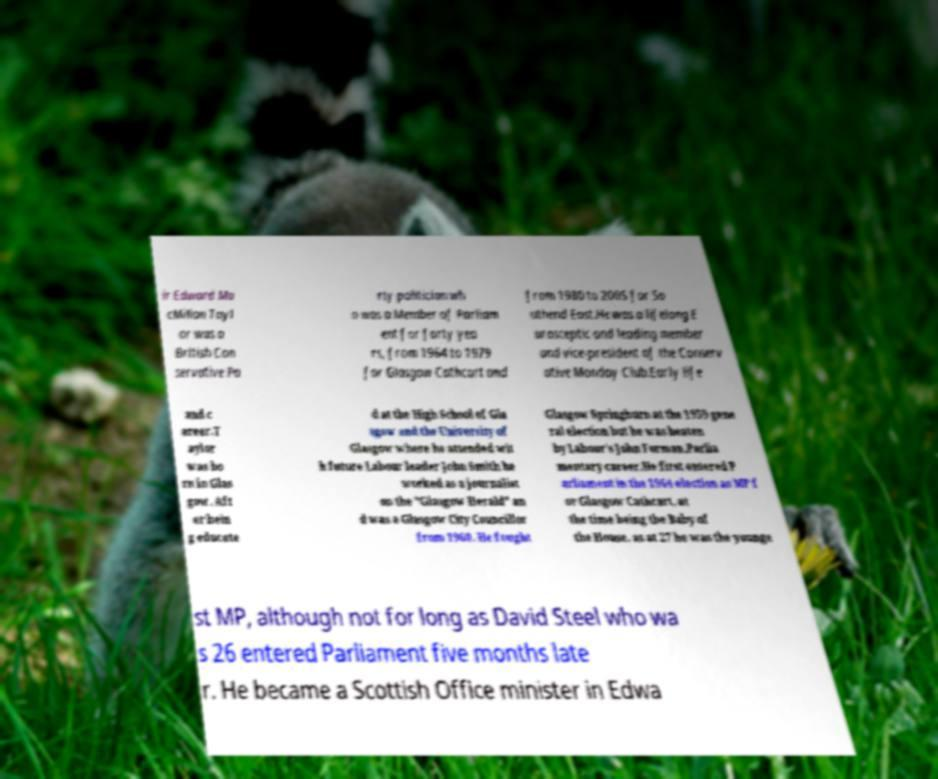Could you assist in decoding the text presented in this image and type it out clearly? ir Edward Ma cMillan Tayl or was a British Con servative Pa rty politician wh o was a Member of Parliam ent for forty yea rs, from 1964 to 1979 for Glasgow Cathcart and from 1980 to 2005 for So uthend East.He was a lifelong E urosceptic and leading member and vice-president of the Conserv ative Monday Club.Early life and c areer.T aylor was bo rn in Glas gow. Aft er bein g educate d at the High School of Gla sgow and the University of Glasgow where he attended wit h future Labour leader John Smith he worked as a journalist on the "Glasgow Herald" an d was a Glasgow City Councillor from 1960. He fought Glasgow Springburn at the 1959 gene ral election but he was beaten by Labour's John Forman.Parlia mentary career.He first entered P arliament in the 1964 election as MP f or Glasgow Cathcart, at the time being the Baby of the House, as at 27 he was the younge st MP, although not for long as David Steel who wa s 26 entered Parliament five months late r. He became a Scottish Office minister in Edwa 